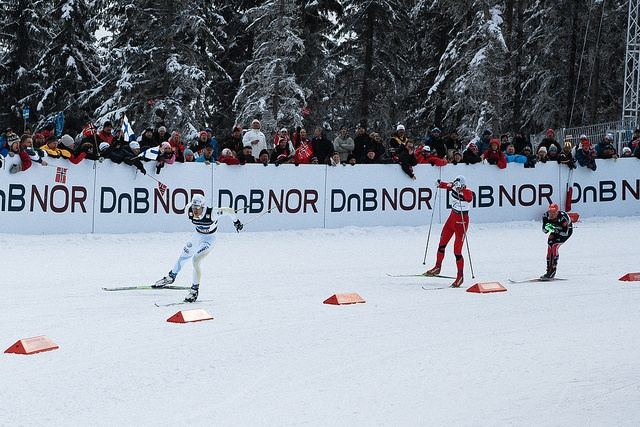Describe the objects in this image and their specific colors. I can see people in lightgray, black, lightblue, and gray tones, people in lightgray, lavender, lightblue, and black tones, people in lightgray, maroon, and black tones, people in lightgray, black, gray, darkgray, and brown tones, and skis in lightgray, darkgray, gray, and black tones in this image. 